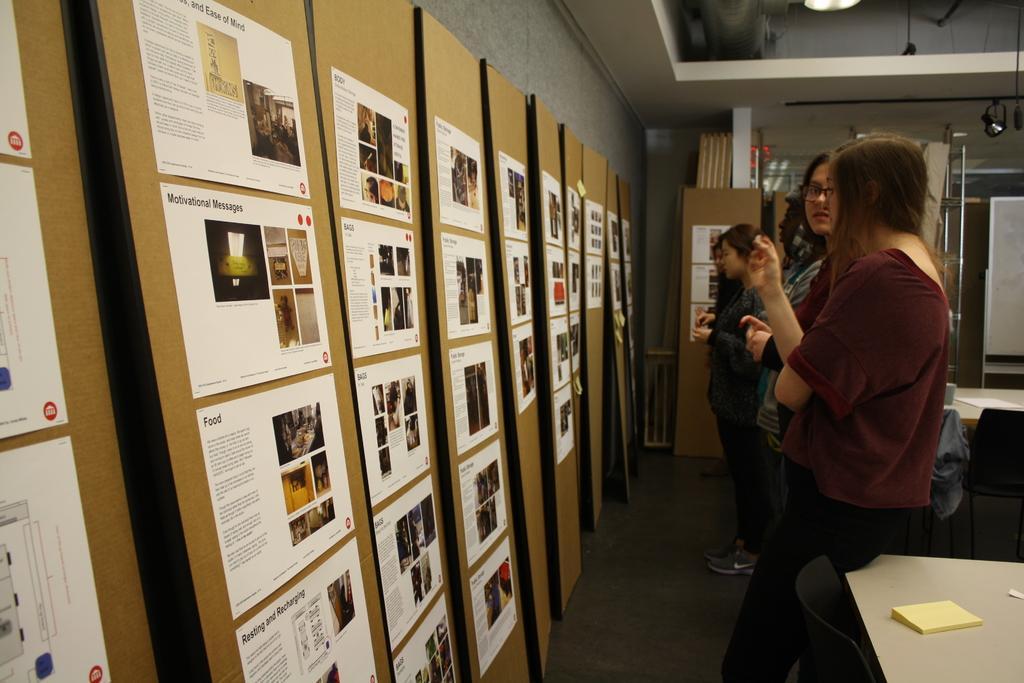How would you summarize this image in a sentence or two? In this image, we can see people and there are papers with some text are pasted on the boards and we can see stands, lights and some other objects. At the bottom, there are chairs and we can see papers on the tables. 